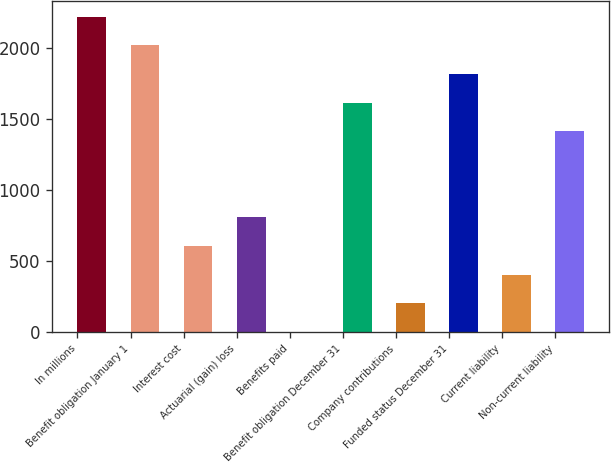<chart> <loc_0><loc_0><loc_500><loc_500><bar_chart><fcel>In millions<fcel>Benefit obligation January 1<fcel>Interest cost<fcel>Actuarial (gain) loss<fcel>Benefits paid<fcel>Benefit obligation December 31<fcel>Company contributions<fcel>Funded status December 31<fcel>Current liability<fcel>Non-current liability<nl><fcel>2219.7<fcel>2018<fcel>606.1<fcel>807.8<fcel>1<fcel>1614.6<fcel>202.7<fcel>1816.3<fcel>404.4<fcel>1412.9<nl></chart> 